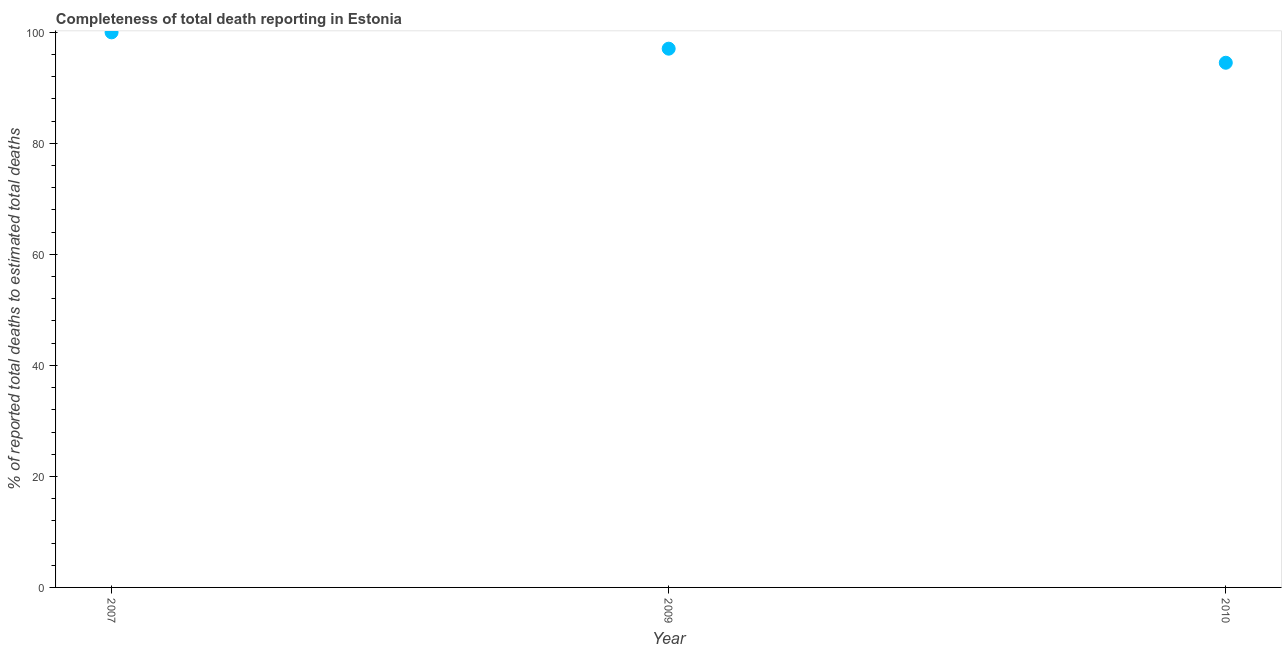What is the completeness of total death reports in 2009?
Your response must be concise. 97.06. Across all years, what is the minimum completeness of total death reports?
Ensure brevity in your answer.  94.52. In which year was the completeness of total death reports minimum?
Give a very brief answer. 2010. What is the sum of the completeness of total death reports?
Your answer should be compact. 291.58. What is the difference between the completeness of total death reports in 2009 and 2010?
Your response must be concise. 2.54. What is the average completeness of total death reports per year?
Offer a terse response. 97.19. What is the median completeness of total death reports?
Your answer should be compact. 97.06. What is the ratio of the completeness of total death reports in 2007 to that in 2009?
Give a very brief answer. 1.03. Is the difference between the completeness of total death reports in 2009 and 2010 greater than the difference between any two years?
Ensure brevity in your answer.  No. What is the difference between the highest and the second highest completeness of total death reports?
Ensure brevity in your answer.  2.94. Is the sum of the completeness of total death reports in 2007 and 2009 greater than the maximum completeness of total death reports across all years?
Offer a very short reply. Yes. What is the difference between the highest and the lowest completeness of total death reports?
Keep it short and to the point. 5.48. Are the values on the major ticks of Y-axis written in scientific E-notation?
Provide a short and direct response. No. Does the graph contain any zero values?
Keep it short and to the point. No. Does the graph contain grids?
Ensure brevity in your answer.  No. What is the title of the graph?
Your response must be concise. Completeness of total death reporting in Estonia. What is the label or title of the Y-axis?
Offer a very short reply. % of reported total deaths to estimated total deaths. What is the % of reported total deaths to estimated total deaths in 2007?
Your answer should be compact. 100. What is the % of reported total deaths to estimated total deaths in 2009?
Your answer should be compact. 97.06. What is the % of reported total deaths to estimated total deaths in 2010?
Give a very brief answer. 94.52. What is the difference between the % of reported total deaths to estimated total deaths in 2007 and 2009?
Your response must be concise. 2.94. What is the difference between the % of reported total deaths to estimated total deaths in 2007 and 2010?
Offer a very short reply. 5.48. What is the difference between the % of reported total deaths to estimated total deaths in 2009 and 2010?
Give a very brief answer. 2.54. What is the ratio of the % of reported total deaths to estimated total deaths in 2007 to that in 2010?
Make the answer very short. 1.06. 